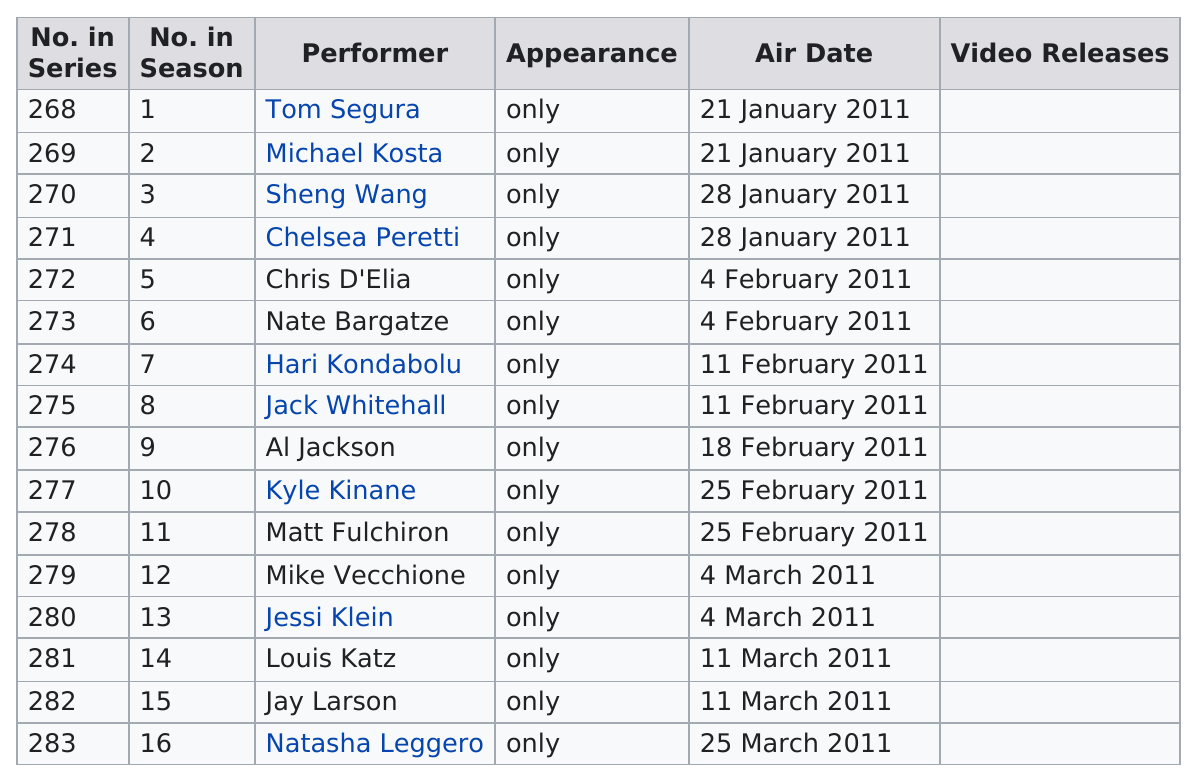Identify some key points in this picture. Tom Segura appeared first compared to Jay Larson. Sixteen comedians made their only appearance on "Comedy Central Presents" in season 15. The month with the most performers was February. Did Kyle Kinane air before or after Al Jackson? Before. February had the most air dates out of all the months. 